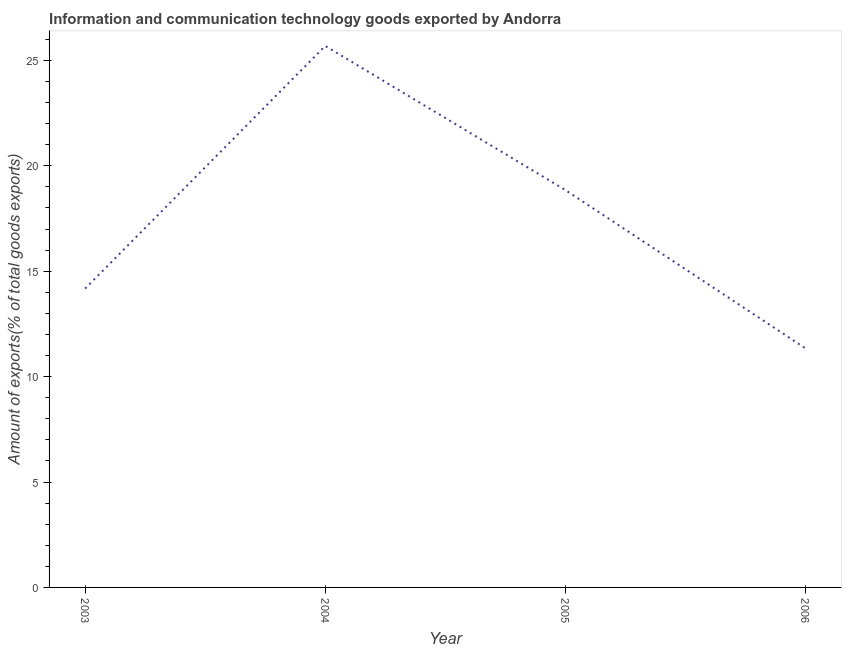What is the amount of ict goods exports in 2005?
Make the answer very short. 18.85. Across all years, what is the maximum amount of ict goods exports?
Your answer should be very brief. 25.68. Across all years, what is the minimum amount of ict goods exports?
Your answer should be compact. 11.34. In which year was the amount of ict goods exports minimum?
Provide a short and direct response. 2006. What is the sum of the amount of ict goods exports?
Ensure brevity in your answer.  70.04. What is the difference between the amount of ict goods exports in 2005 and 2006?
Offer a very short reply. 7.51. What is the average amount of ict goods exports per year?
Offer a terse response. 17.51. What is the median amount of ict goods exports?
Keep it short and to the point. 16.51. In how many years, is the amount of ict goods exports greater than 23 %?
Offer a very short reply. 1. Do a majority of the years between 2004 and 2005 (inclusive) have amount of ict goods exports greater than 16 %?
Ensure brevity in your answer.  Yes. What is the ratio of the amount of ict goods exports in 2004 to that in 2006?
Give a very brief answer. 2.26. Is the amount of ict goods exports in 2004 less than that in 2006?
Your response must be concise. No. Is the difference between the amount of ict goods exports in 2003 and 2006 greater than the difference between any two years?
Give a very brief answer. No. What is the difference between the highest and the second highest amount of ict goods exports?
Give a very brief answer. 6.84. Is the sum of the amount of ict goods exports in 2003 and 2006 greater than the maximum amount of ict goods exports across all years?
Keep it short and to the point. No. What is the difference between the highest and the lowest amount of ict goods exports?
Your response must be concise. 14.34. In how many years, is the amount of ict goods exports greater than the average amount of ict goods exports taken over all years?
Your response must be concise. 2. Does the amount of ict goods exports monotonically increase over the years?
Give a very brief answer. No. How many lines are there?
Your answer should be very brief. 1. How many years are there in the graph?
Ensure brevity in your answer.  4. Are the values on the major ticks of Y-axis written in scientific E-notation?
Give a very brief answer. No. Does the graph contain any zero values?
Provide a succinct answer. No. What is the title of the graph?
Offer a terse response. Information and communication technology goods exported by Andorra. What is the label or title of the Y-axis?
Provide a succinct answer. Amount of exports(% of total goods exports). What is the Amount of exports(% of total goods exports) of 2003?
Give a very brief answer. 14.17. What is the Amount of exports(% of total goods exports) in 2004?
Provide a short and direct response. 25.68. What is the Amount of exports(% of total goods exports) of 2005?
Your answer should be compact. 18.85. What is the Amount of exports(% of total goods exports) of 2006?
Give a very brief answer. 11.34. What is the difference between the Amount of exports(% of total goods exports) in 2003 and 2004?
Give a very brief answer. -11.51. What is the difference between the Amount of exports(% of total goods exports) in 2003 and 2005?
Your answer should be compact. -4.67. What is the difference between the Amount of exports(% of total goods exports) in 2003 and 2006?
Your answer should be compact. 2.84. What is the difference between the Amount of exports(% of total goods exports) in 2004 and 2005?
Make the answer very short. 6.84. What is the difference between the Amount of exports(% of total goods exports) in 2004 and 2006?
Your answer should be compact. 14.34. What is the difference between the Amount of exports(% of total goods exports) in 2005 and 2006?
Make the answer very short. 7.51. What is the ratio of the Amount of exports(% of total goods exports) in 2003 to that in 2004?
Make the answer very short. 0.55. What is the ratio of the Amount of exports(% of total goods exports) in 2003 to that in 2005?
Your answer should be very brief. 0.75. What is the ratio of the Amount of exports(% of total goods exports) in 2003 to that in 2006?
Give a very brief answer. 1.25. What is the ratio of the Amount of exports(% of total goods exports) in 2004 to that in 2005?
Offer a terse response. 1.36. What is the ratio of the Amount of exports(% of total goods exports) in 2004 to that in 2006?
Offer a very short reply. 2.27. What is the ratio of the Amount of exports(% of total goods exports) in 2005 to that in 2006?
Your answer should be compact. 1.66. 